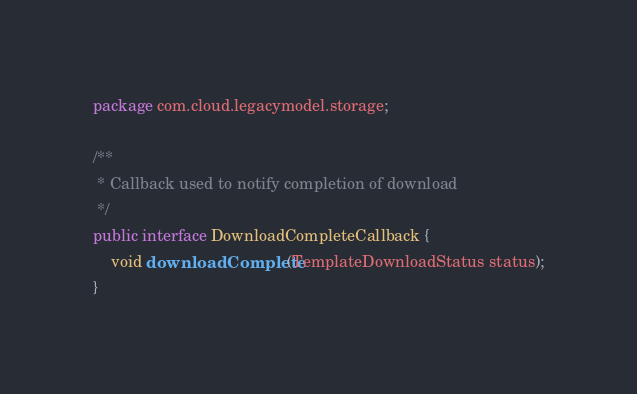Convert code to text. <code><loc_0><loc_0><loc_500><loc_500><_Java_>package com.cloud.legacymodel.storage;

/**
 * Callback used to notify completion of download
 */
public interface DownloadCompleteCallback {
    void downloadComplete(TemplateDownloadStatus status);
}
</code> 